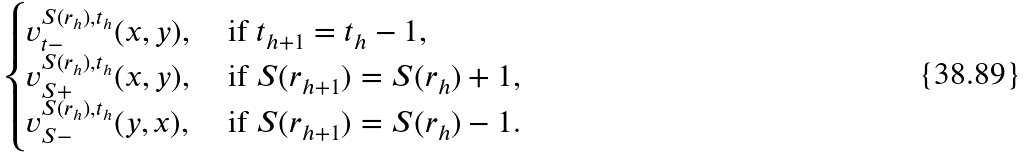<formula> <loc_0><loc_0><loc_500><loc_500>\begin{cases} v _ { t - } ^ { S ( r _ { h } ) , t _ { h } } ( x , y ) , & \text { if } t _ { h + 1 } = t _ { h } - 1 , \\ v _ { S + } ^ { S ( r _ { h } ) , t _ { h } } ( x , y ) , & \text { if } S ( r _ { h + 1 } ) = S ( r _ { h } ) + 1 , \\ v _ { S - } ^ { S ( r _ { h } ) , t _ { h } } ( y , x ) , & \text { if } S ( r _ { h + 1 } ) = S ( r _ { h } ) - 1 . \end{cases}</formula> 